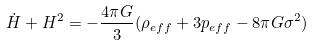Convert formula to latex. <formula><loc_0><loc_0><loc_500><loc_500>\dot { H } + H ^ { 2 } = - \frac { 4 { \pi } G } { 3 } ( { \rho } _ { e f f } + 3 p _ { e f f } - 8 { \pi } G { \sigma } ^ { 2 } )</formula> 